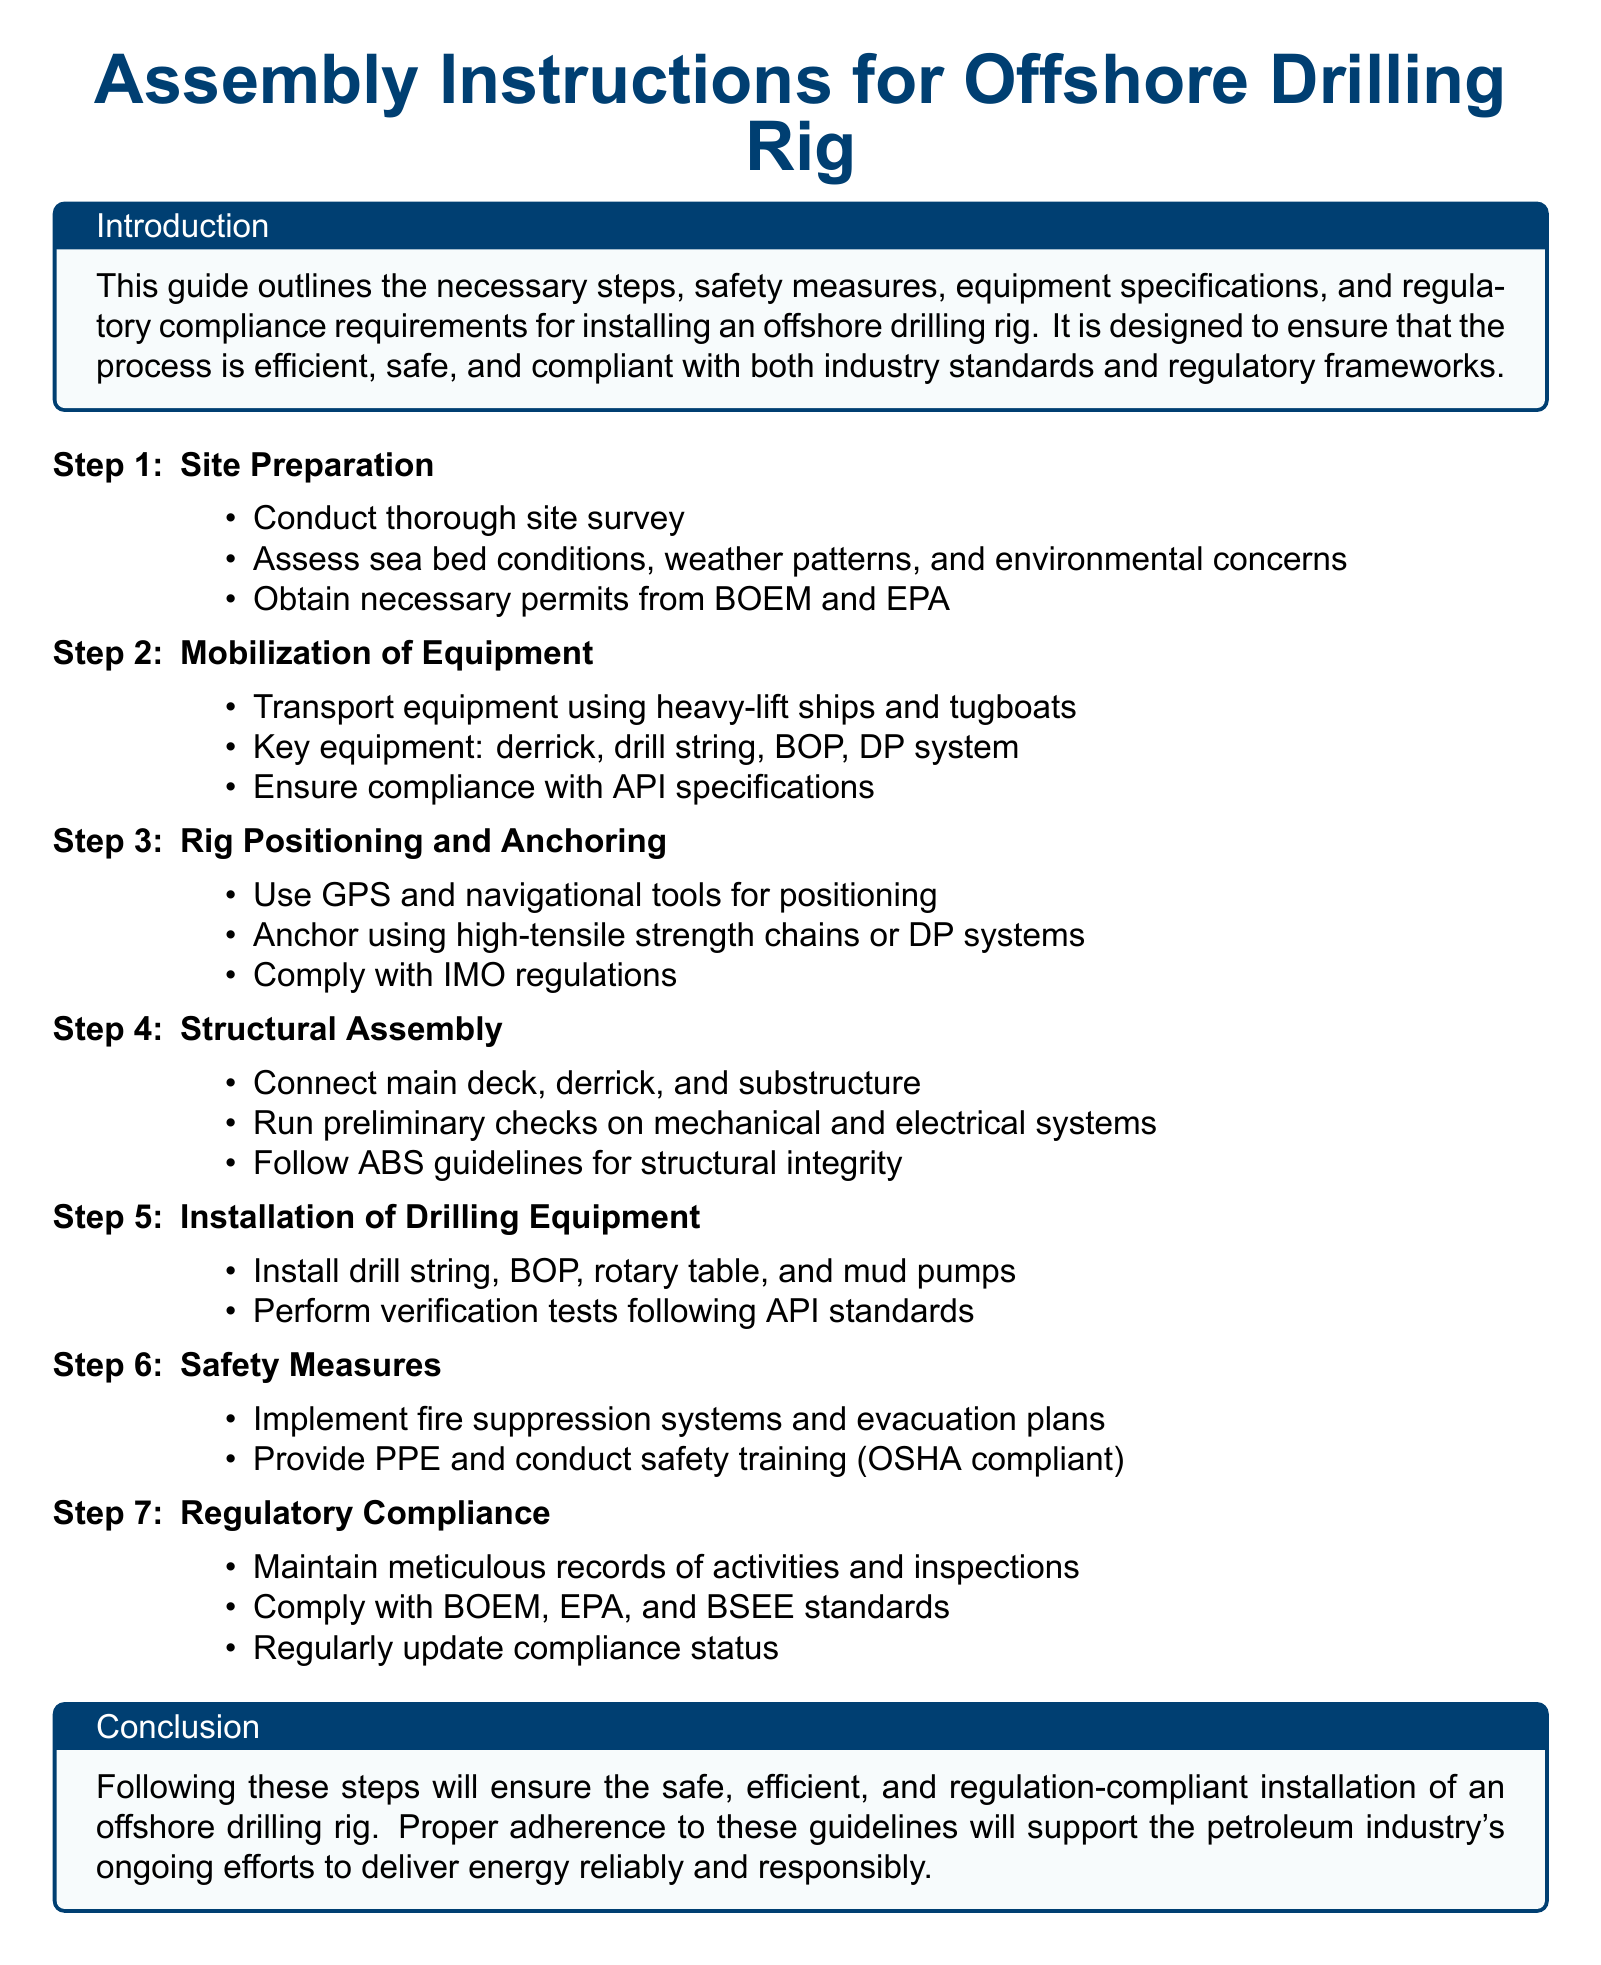What is the title of the document? The title is prominently displayed at the top of the document.
Answer: Assembly Instructions for Offshore Drilling Rig What is the first step in the installation process? The first step is listed in the ordered list at the beginning of the procedures.
Answer: Site Preparation Which organization’s permits are necessary for site preparation? The document mentions specific organizations related to regulatory compliance in the permits section.
Answer: BOEM and EPA What type of ships are used for equipment mobilization? The type of transportation for equipment is detailed in the equipment mobilization step.
Answer: Heavy-lift ships What does PPE stand for in the context of safety measures? The abbreviation is commonly defined in safety guidelines within the document.
Answer: Personal Protective Equipment Which system is used for rig positioning? The procedure for positioning includes a specific technology used for navigation.
Answer: GPS How many key pieces of equipment are listed under mobilization? The number of items mentioned in the equipment mobilization section is specific.
Answer: Four What guidelines should be followed for structural integrity? The document specifies which guidelines are applicable to ensure structural safety.
Answer: ABS What is required for regulatory compliance? The section clearly states what is necessary to maintain compliance in offshore drilling operations.
Answer: Meticulous records of activities and inspections 